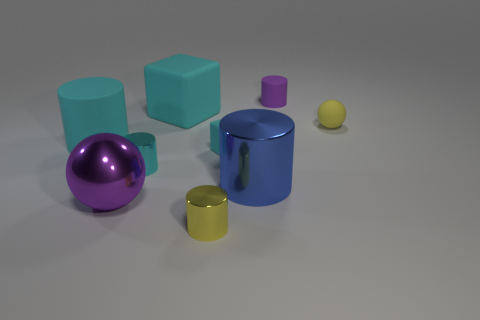Is there anything else that has the same shape as the small cyan matte object?
Provide a short and direct response. Yes. Is the number of big cyan rubber blocks that are right of the blue metal cylinder the same as the number of metal objects?
Provide a short and direct response. No. Does the big matte block have the same color as the tiny matte thing to the left of the tiny purple thing?
Make the answer very short. Yes. The cylinder that is both right of the small block and on the left side of the purple rubber thing is what color?
Provide a short and direct response. Blue. What number of tiny yellow things are right of the large shiny thing that is on the right side of the purple ball?
Your answer should be very brief. 1. Are there any big matte objects of the same shape as the tiny yellow metal object?
Ensure brevity in your answer.  Yes. There is a purple object in front of the small yellow matte ball; does it have the same shape as the small yellow thing that is behind the tiny cyan metallic object?
Your answer should be compact. Yes. How many objects are either large blue metal cylinders or large cyan matte cubes?
Provide a short and direct response. 2. What size is the blue thing that is the same shape as the tiny purple matte object?
Offer a terse response. Large. Are there more cylinders that are in front of the big blue metal object than yellow shiny cubes?
Your answer should be very brief. Yes. 